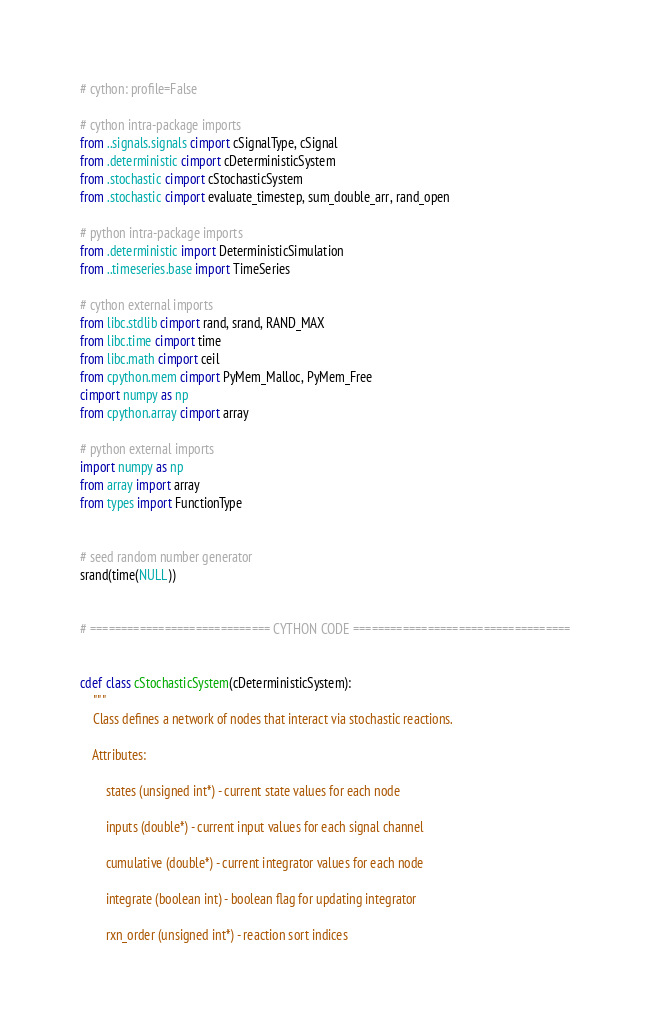<code> <loc_0><loc_0><loc_500><loc_500><_Cython_># cython: profile=False

# cython intra-package imports
from ..signals.signals cimport cSignalType, cSignal
from .deterministic cimport cDeterministicSystem
from .stochastic cimport cStochasticSystem
from .stochastic cimport evaluate_timestep, sum_double_arr, rand_open

# python intra-package imports
from .deterministic import DeterministicSimulation
from ..timeseries.base import TimeSeries

# cython external imports
from libc.stdlib cimport rand, srand, RAND_MAX
from libc.time cimport time
from libc.math cimport ceil
from cpython.mem cimport PyMem_Malloc, PyMem_Free
cimport numpy as np
from cpython.array cimport array

# python external imports
import numpy as np
from array import array
from types import FunctionType


# seed random number generator
srand(time(NULL))


# ============================= CYTHON CODE ===================================


cdef class cStochasticSystem(cDeterministicSystem):
    """
    Class defines a network of nodes that interact via stochastic reactions.

    Attributes:

        states (unsigned int*) - current state values for each node

        inputs (double*) - current input values for each signal channel

        cumulative (double*) - current integrator values for each node

        integrate (boolean int) - boolean flag for updating integrator

        rxn_order (unsigned int*) - reaction sort indices
</code> 